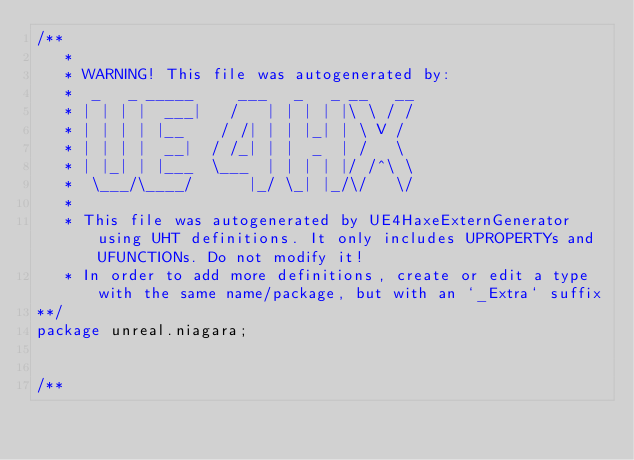<code> <loc_0><loc_0><loc_500><loc_500><_Haxe_>/**
   * 
   * WARNING! This file was autogenerated by: 
   *  _   _ _____     ___   _   _ __   __ 
   * | | | |  ___|   /   | | | | |\ \ / / 
   * | | | | |__    / /| | | |_| | \ V /  
   * | | | |  __|  / /_| | |  _  | /   \  
   * | |_| | |___  \___  | | | | |/ /^\ \ 
   *  \___/\____/      |_/ \_| |_/\/   \/ 
   * 
   * This file was autogenerated by UE4HaxeExternGenerator using UHT definitions. It only includes UPROPERTYs and UFUNCTIONs. Do not modify it!
   * In order to add more definitions, create or edit a type with the same name/package, but with an `_Extra` suffix
**/
package unreal.niagara;


/**</code> 